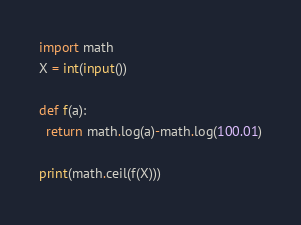<code> <loc_0><loc_0><loc_500><loc_500><_Python_>import math
X = int(input())
 
def f(a):
  return math.log(a)-math.log(100.01)
 
print(math.ceil(f(X)))

</code> 